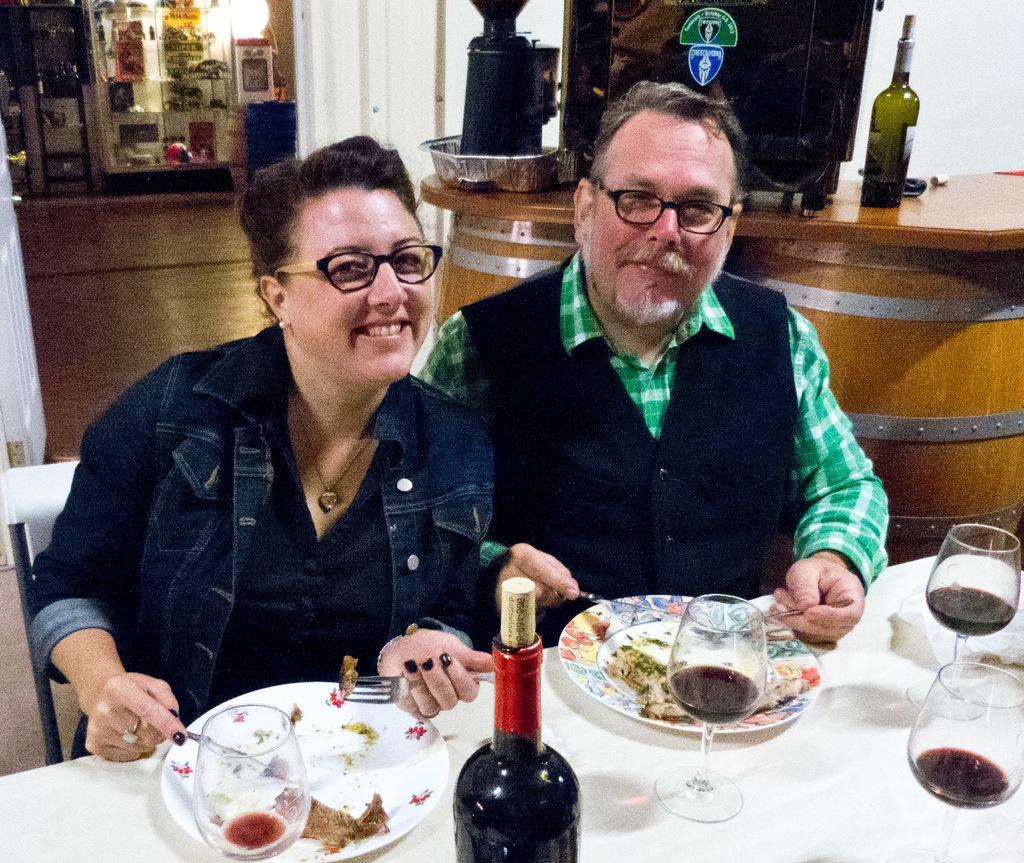How would you summarize this image in a sentence or two? In this picture we can see a man and woman, they are seated and they wore spectacles, in front of them we can find few plates, glasses and a bottle on the table, in the background we can see a light and few things in the racks, on the right side of the image we can see a bottle and other things on the barrels. 